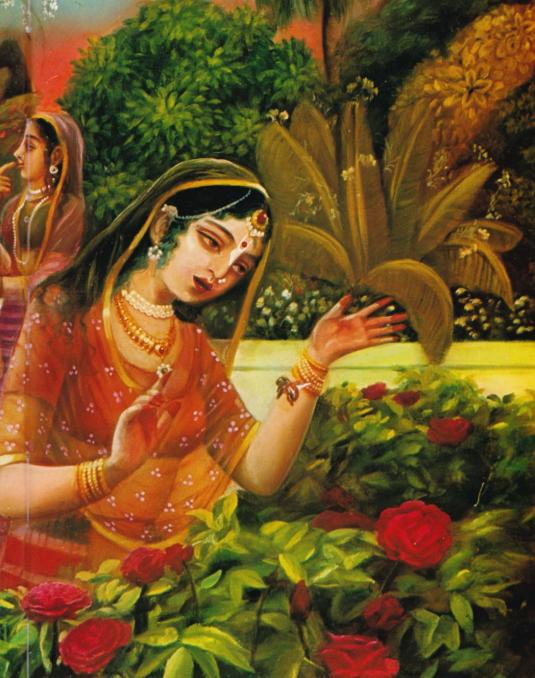What might be the cultural significance or story behind the primary woman's pose and expression as she reaches out to the roses, and how does this tie into the possible narrative or theme suggested by the painting? The woman's pose and expression, coupled with her elaborate attire, suggest a scene of deep cultural significance rooted in Indian traditions. Her gesture towards the roses could be interpreted in multiple ways, such as an act of worship, symbolizing purity and devotion, or an appreciation of nature's beauty. This portrayal is evocative of classical Indian stories or mythology where women are often depicted in such serene and contemplative moments. The lush setting, with vibrant flora, may signify a garden of spiritual or royal importance. The woman in the background enhances the narrative, hinting at the presence of a companion, which adds a layer of social or communal context, possibly indicating rituals, festivals, or shared experiences. Overall, the painting captures a sense of elegance, emotional depth, and cultural richness, inviting viewers to appreciate its serene beauty and thematic depth. 